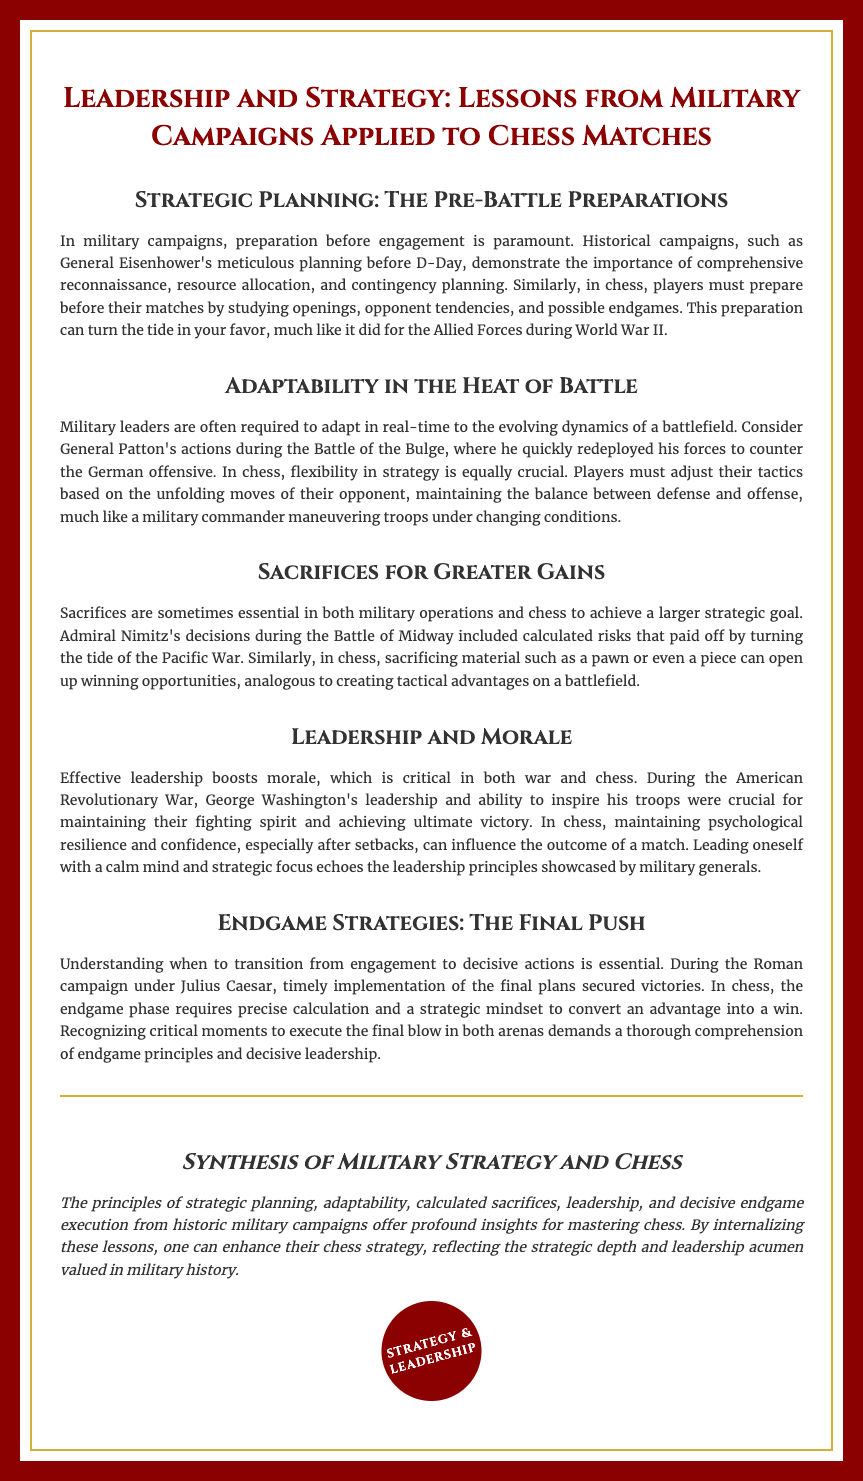what is the title of the diploma? The title of the diploma is displayed prominently at the top of the document, summarizing its focus.
Answer: Leadership and Strategy: Lessons from Military Campaigns Applied to Chess Matches who is mentioned in connection with D-Day? This military leader is noted for meticulous planning prior to a significant military operation.
Answer: General Eisenhower which battle does General Patton's actions relate to? The document refers to a specific military confrontation where adaptability was crucial.
Answer: Battle of the Bulge what is emphasized as critical for maintaining fighting spirit in war? Leadership's impact on morale is highlighted as essential for success during military engagements.
Answer: Effective leadership which strategy is linked with Admiral Nimitz's decisions? The document discusses risk-taking as a necessary tactic in both military and chess contexts.
Answer: Calculated risks what should be understood at the endgame phase in chess? The document stresses a specific mindset needed to convert an advantage into victory during this phase.
Answer: Precise calculation what leadership principle is illustrated through George Washington? The document illustrates how one aspect of leadership contributed to troop morale and success.
Answer: Ability to inspire what is the main theme of the conclusion? The conclusion encapsulates the essence of the lessons drawn from military history applied to chess.
Answer: Synthesis of Military Strategy and Chess 